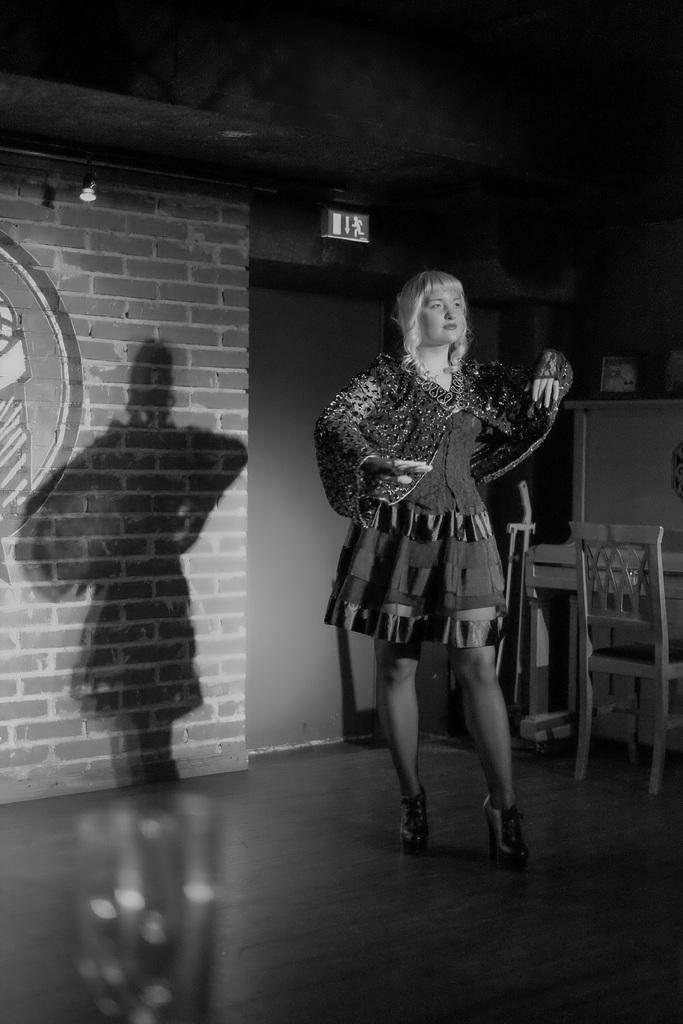What is the color scheme of the image? The image is in black and white. What can be seen in the foreground of the image? There is a woman standing in the image. What furniture is present in the image? There is a table with a chair beside the woman. What is visible behind the woman? There is a wall behind the woman. What type of lighting is present in the image? There are lights in the image. What is hanging from the ceiling in the image? There is a sign board on the ceiling. Can you see any bones or volcanoes in the image? No, there are no bones or volcanoes present in the image. What type of waves can be seen in the image? There are no waves visible in the image, as it is a black and white image of a woman standing near a table and chair. 